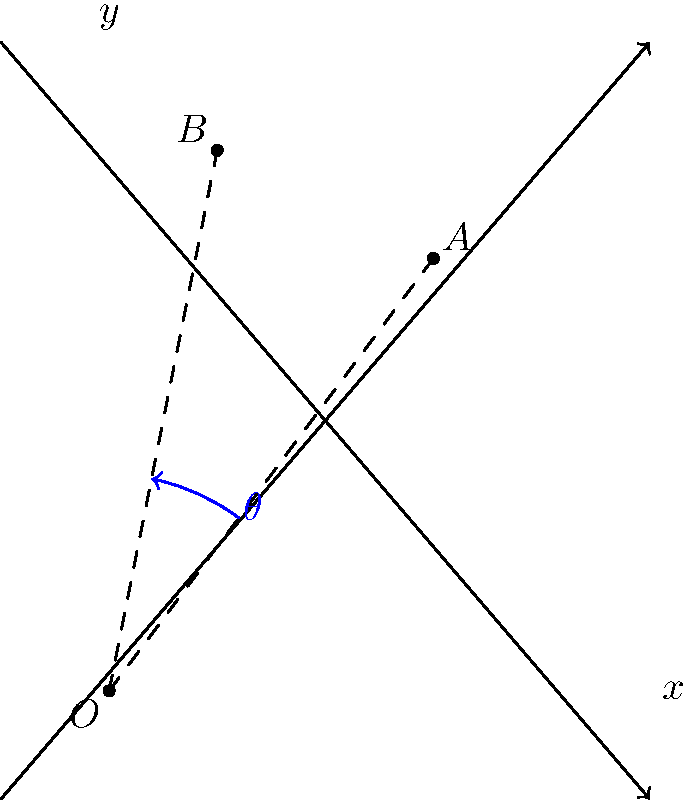A vintage toy robot is positioned at point $A(3,4)$ in a coordinate system. It rotates counterclockwise around the origin $O(0,0)$ to a new position at point $B(1,5)$. Calculate the angle of rotation $\theta$ in radians, rounded to two decimal places. To find the angle of rotation $\theta$, we can use the dot product formula for the cosine of the angle between two vectors:

1) First, we need to create vectors $\vec{OA}$ and $\vec{OB}$:
   $\vec{OA} = (3,4)$ and $\vec{OB} = (1,5)$

2) The dot product formula states:
   $\cos \theta = \frac{\vec{OA} \cdot \vec{OB}}{|\vec{OA}||\vec{OB}|}$

3) Calculate the dot product $\vec{OA} \cdot \vec{OB}$:
   $\vec{OA} \cdot \vec{OB} = (3)(1) + (4)(5) = 3 + 20 = 23$

4) Calculate the magnitudes:
   $|\vec{OA}| = \sqrt{3^2 + 4^2} = \sqrt{25} = 5$
   $|\vec{OB}| = \sqrt{1^2 + 5^2} = \sqrt{26}$

5) Substitute into the formula:
   $\cos \theta = \frac{23}{5\sqrt{26}}$

6) Take the inverse cosine (arccos) of both sides:
   $\theta = \arccos(\frac{23}{5\sqrt{26}})$

7) Calculate and round to two decimal places:
   $\theta \approx 0.39$ radians
Answer: 0.39 radians 